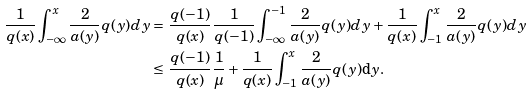Convert formula to latex. <formula><loc_0><loc_0><loc_500><loc_500>\frac { 1 } { q ( x ) } \int _ { - \infty } ^ { x } \frac { 2 } { a ( y ) } q ( y ) d y = & \ \frac { q ( - 1 ) } { q ( x ) } \frac { 1 } { q ( - 1 ) } \int _ { - \infty } ^ { - 1 } \frac { 2 } { a ( y ) } q ( y ) d y + \frac { 1 } { q ( x ) } \int _ { - 1 } ^ { x } \frac { 2 } { a ( y ) } q ( y ) d y \\ \leq & \ \frac { q ( - 1 ) } { q ( x ) } \frac { 1 } { \mu } + \frac { 1 } { q ( x ) } \int _ { - 1 } ^ { x } \frac { 2 } { a ( y ) } q ( y ) \mathrm d y .</formula> 